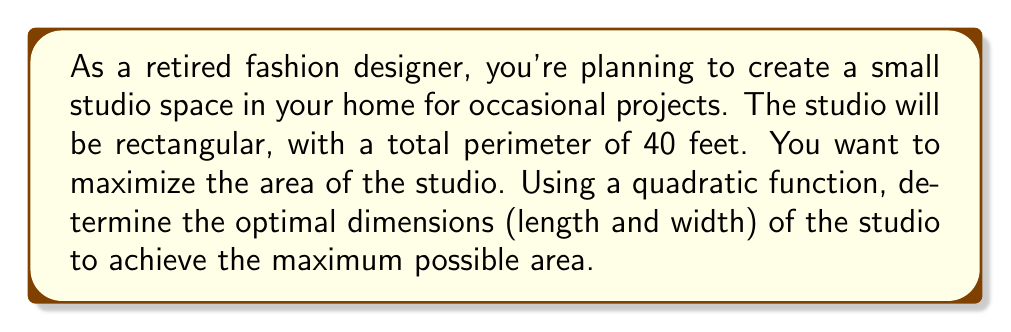Give your solution to this math problem. Let's approach this step-by-step:

1) Let $x$ be the width of the studio and $y$ be the length.

2) Given that the perimeter is 40 feet, we can write:
   $$2x + 2y = 40$$

3) Solving for $y$:
   $$y = 20 - x$$

4) The area of the studio is given by $A = xy$. Substituting $y$:
   $$A = x(20-x) = 20x - x^2$$

5) This is a quadratic function. To find the maximum, we need to find the vertex of this parabola.

6) For a quadratic function in the form $f(x) = ax^2 + bx + c$, the x-coordinate of the vertex is given by $-b/(2a)$.

7) In our case, $a = -1$, $b = 20$, and $c = 0$. So:
   $$x = -20/(-2) = 10$$

8) This means the width should be 10 feet. To find the length, we substitute back:
   $$y = 20 - 10 = 10$$

9) To verify this is a maximum, we can check that the parabola opens downward (which it does, since $a$ is negative).

10) The maximum area is therefore:
    $$A = 10 * 10 = 100$$ square feet
Answer: The optimal dimensions for the studio are 10 feet by 10 feet, giving a maximum area of 100 square feet. 